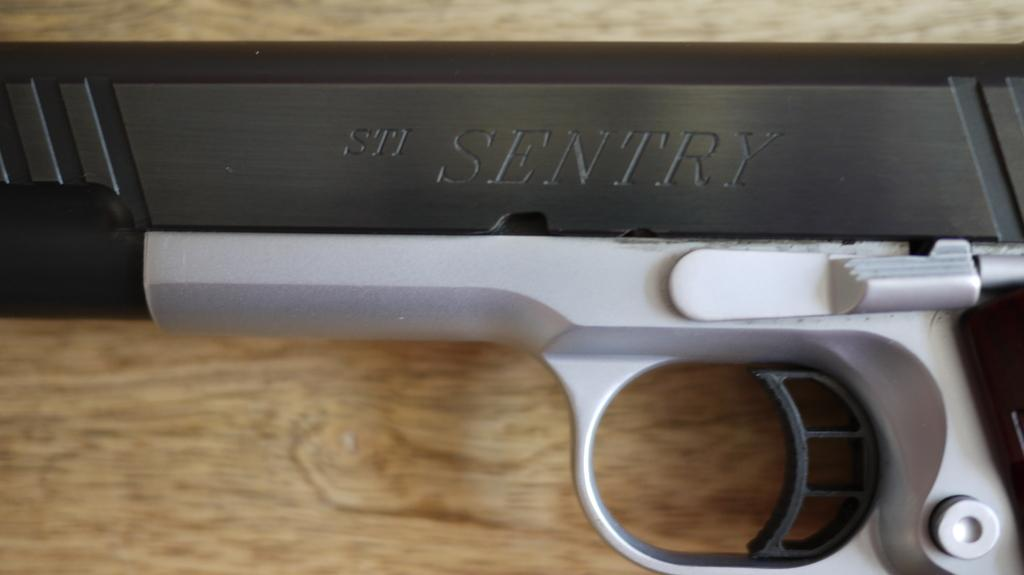What is the main object in the image? There is a gun in the image. What is the gun resting on? The gun is on a wooden object. What colors can be seen on the gun? The gun is black and silver in color. How does the gun help the sister in the image? There is no mention of a sister in the image, so it is not possible to determine how the gun might help her. 